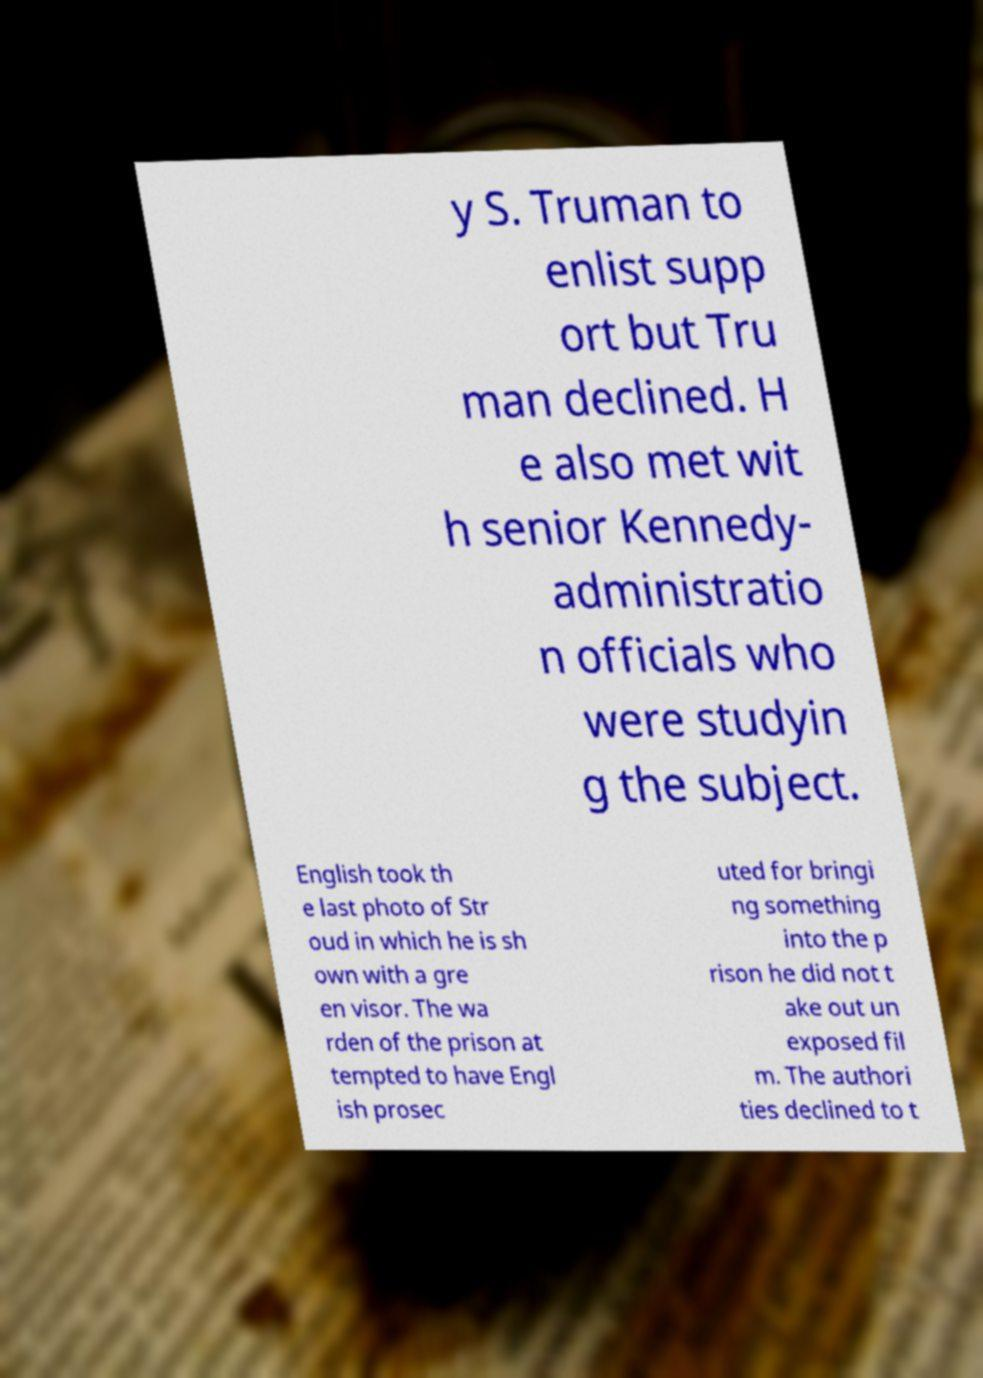Can you read and provide the text displayed in the image?This photo seems to have some interesting text. Can you extract and type it out for me? y S. Truman to enlist supp ort but Tru man declined. H e also met wit h senior Kennedy- administratio n officials who were studyin g the subject. English took th e last photo of Str oud in which he is sh own with a gre en visor. The wa rden of the prison at tempted to have Engl ish prosec uted for bringi ng something into the p rison he did not t ake out un exposed fil m. The authori ties declined to t 